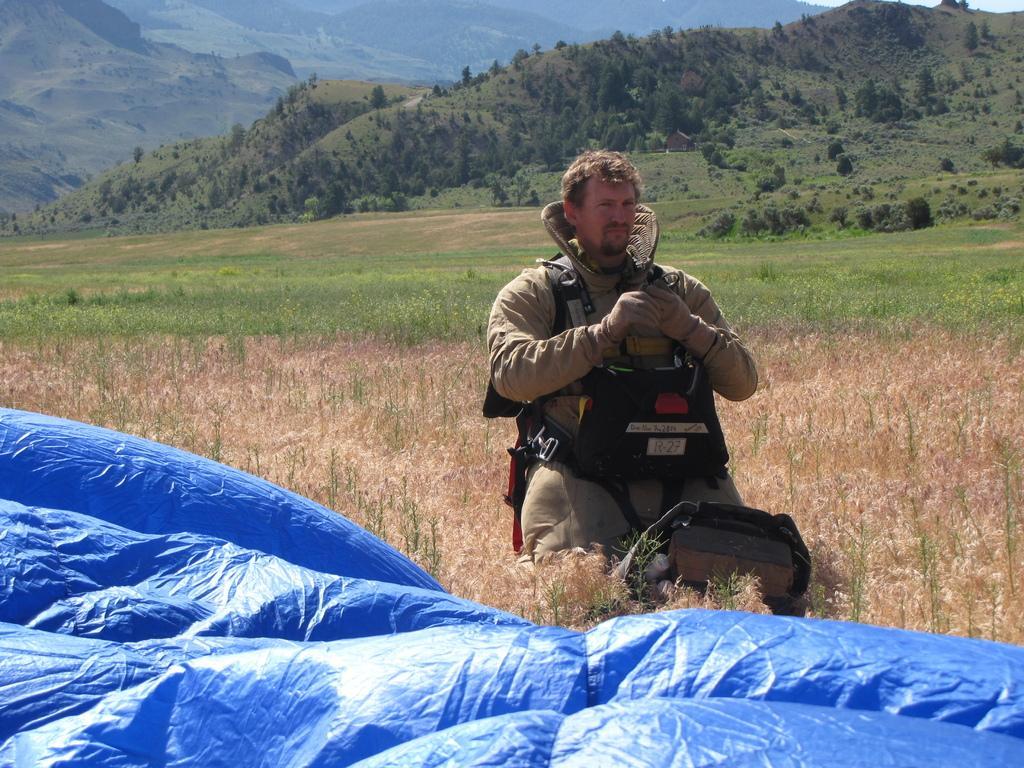How would you summarize this image in a sentence or two? There is a person wearing a jacket, gloves. In front of him there is a bag. Also there is a blue color sheet. In the back there are plants. In the background there are hills with trees. 